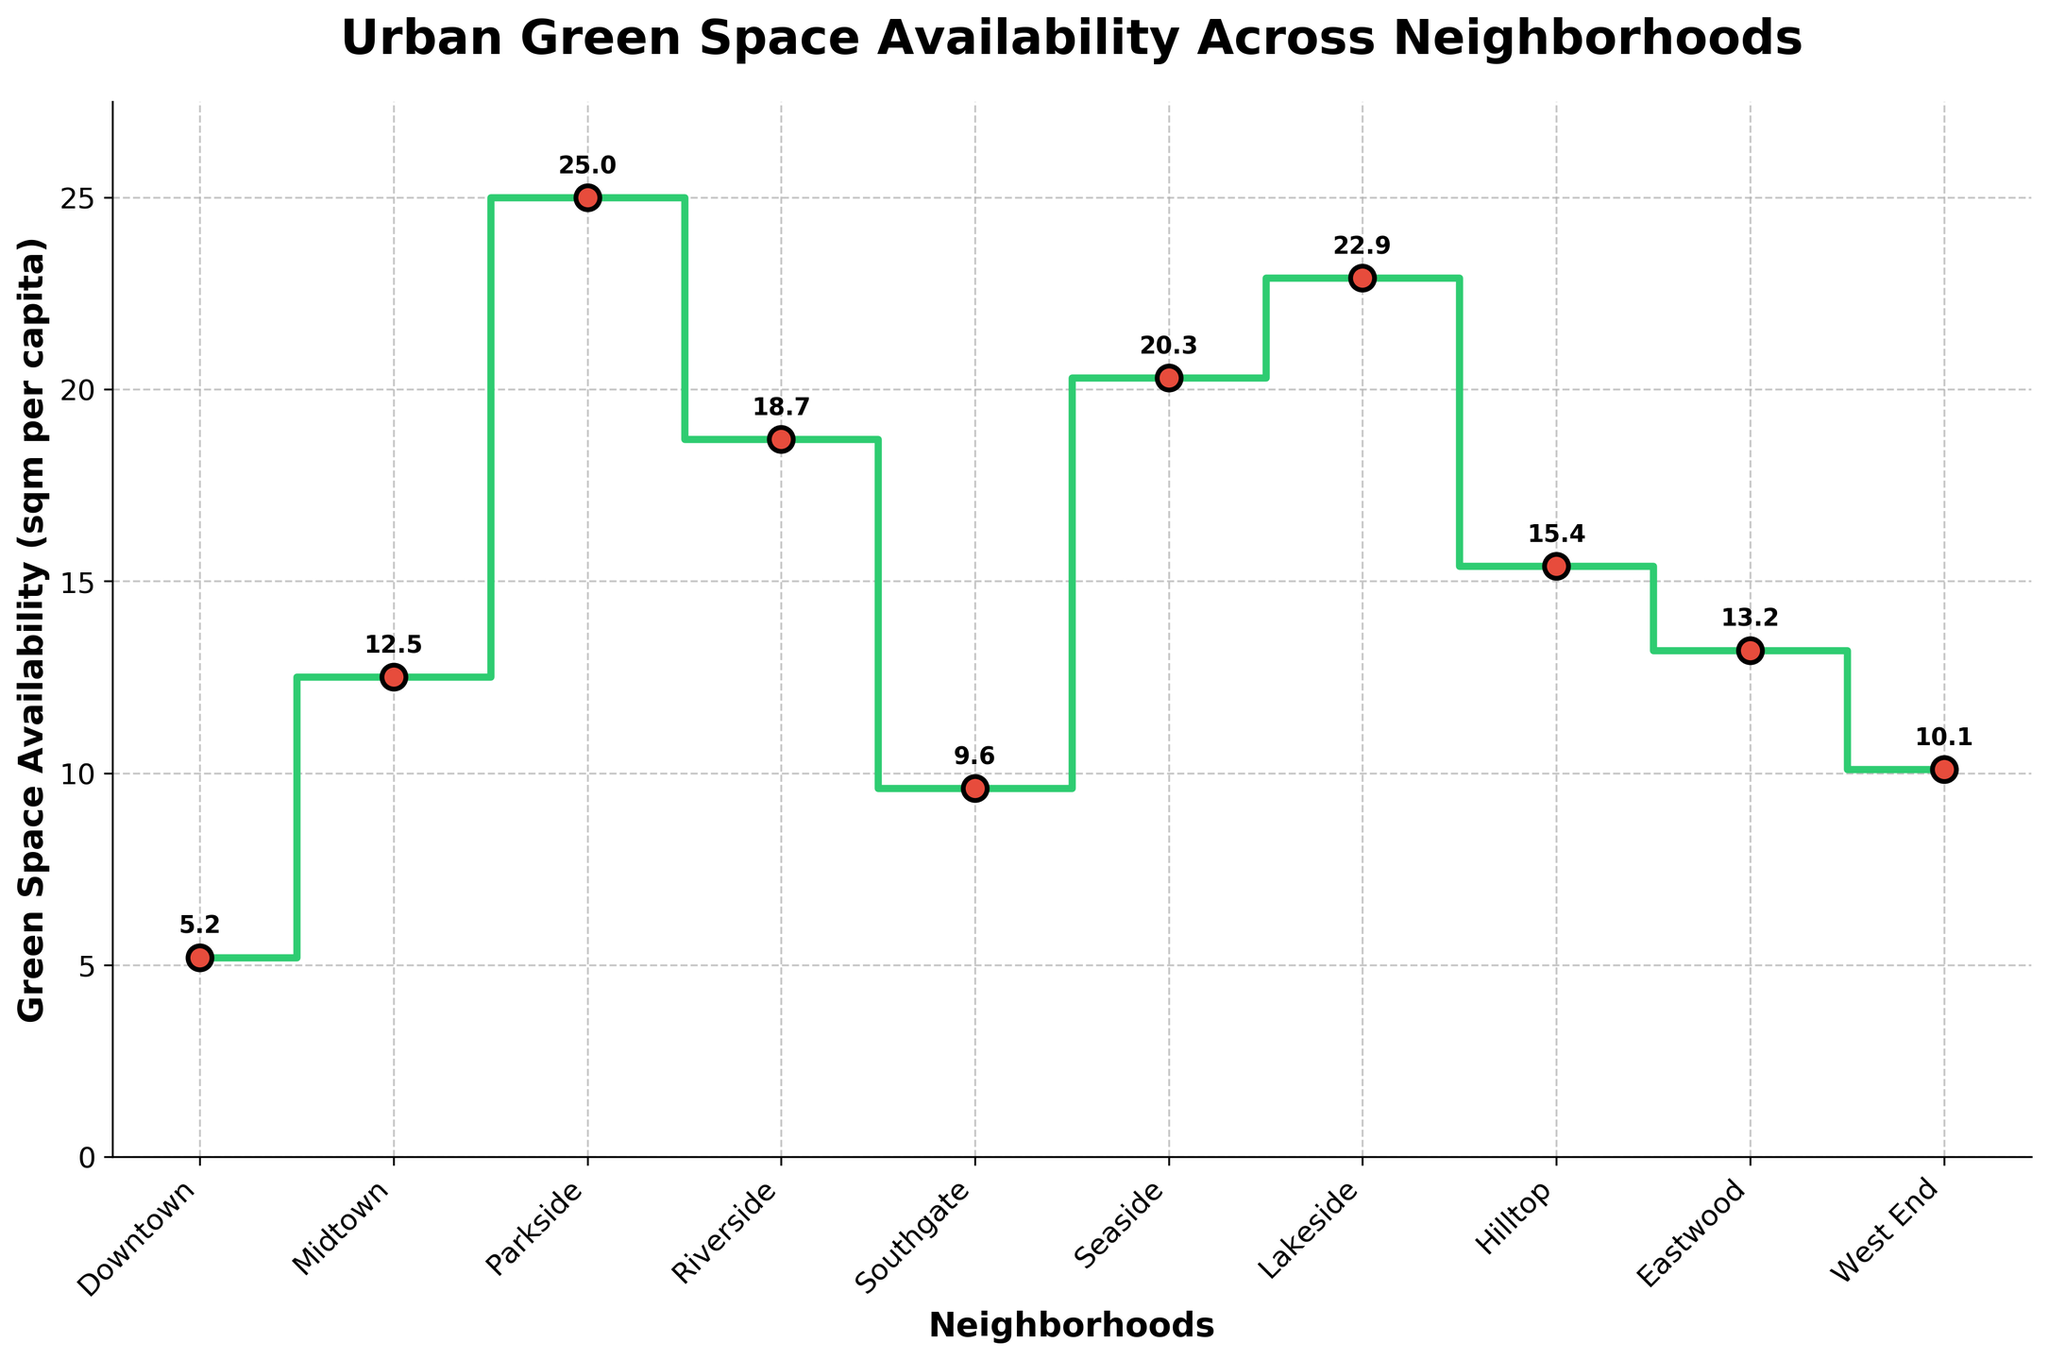What is the title of the figure? The title is displayed at the top of the figure and it provides a summary of what the plot is about. By reading it, you can understand that the figure represents the availability of green spaces in different neighborhoods.
Answer: Urban Green Space Availability Across Neighborhoods Which neighborhood has the highest green space availability? By looking at the green space values plotted for each neighborhood, you can identify the neighborhood with the highest value. Parkside has the highest green space availability with a value of 25.0 sqm per capita.
Answer: Parkside How does Downtown compare to Southgate in terms of green space availability? To compare, look at the values for both neighborhoods. Downtown has a green space availability of 5.2 sqm per capita, while Southgate has 9.6 sqm per capita, which means Southgate has more green space availability than Downtown.
Answer: Southgate has more What is the average green space availability across all neighborhoods? To find the average, sum up all the green space values and divide by the number of neighborhoods. The values are: 5.2, 12.5, 25.0, 18.7, 9.6, 20.3, 22.9, 15.4, 13.2, and 10.1. The total sum is 153.9. There are 10 neighborhoods, so the average is 153.9/10 = 15.39 sqm per capita.
Answer: 15.39 Which neighborhood has the closest green space availability to the average value? The average green space availability is 15.39 sqm per capita. Compare each neighborhood's value to this average. Hilltop has a green space availability of 15.4 sqm per capita, which is the closest to the average.
Answer: Hilltop What is the total green space availability for Seaside and Lakeside combined? Add the green space values for Seaside and Lakeside. Seaside has 20.3 sqm per capita and Lakeside has 22.9 sqm per capita. The total is 20.3 + 22.9 = 43.2 sqm per capita.
Answer: 43.2 How much more green space per capita does Parkside have compared to West End? Subtract the green space value of West End from Parkside's value. Parkside has 25.0 sqm per capita and West End has 10.1 sqm per capita. The difference is 25.0 - 10.1 = 14.9 sqm per capita.
Answer: 14.9 On the x-axis, how many neighborhoods have green space availability greater than 20 sqm per capita? Count the neighborhoods with green space values greater than 20. These neighborhoods are Parkside (25.0), Seaside (20.3), and Lakeside (22.9). There are 3 neighborhoods.
Answer: 3 At which neighborhood do the green space values see the steepest increase when moving from one neighborhood to the next? Examine the steps between neighborhoods to see where the largest increase occurs. The steepest increase is between Midtown (12.5) and Parkside (25.0), an increase of 12.5 sqm per capita.
Answer: Between Midtown and Parkside 